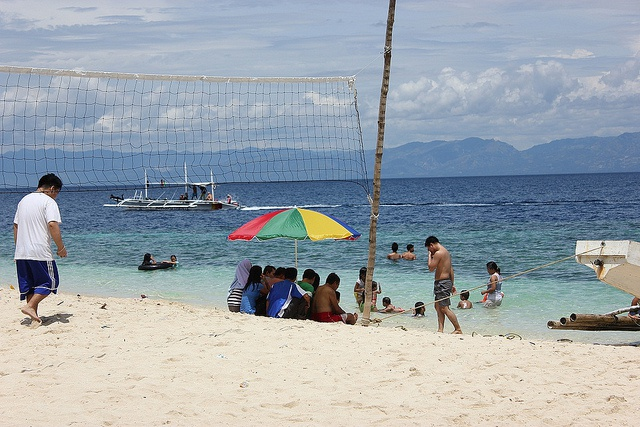Describe the objects in this image and their specific colors. I can see people in darkgray, lavender, black, and navy tones, people in darkgray, black, navy, and gray tones, umbrella in darkgray, turquoise, gold, and salmon tones, boat in darkgray, black, gray, and blue tones, and boat in darkgray, tan, and lightgray tones in this image. 